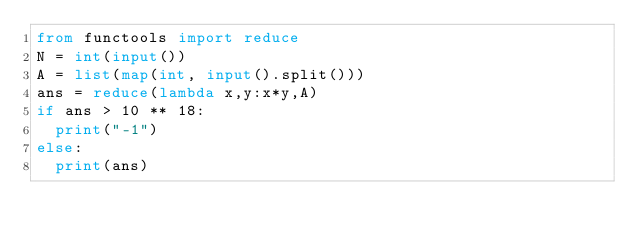<code> <loc_0><loc_0><loc_500><loc_500><_Python_>from functools import reduce
N = int(input())
A = list(map(int, input().split()))
ans = reduce(lambda x,y:x*y,A)
if ans > 10 ** 18:
  print("-1")
else:
  print(ans)</code> 